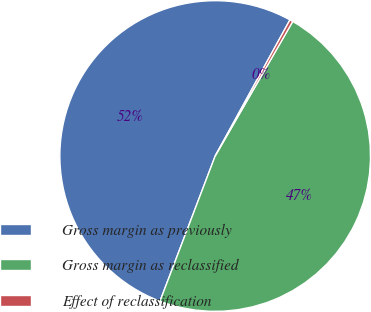Convert chart to OTSL. <chart><loc_0><loc_0><loc_500><loc_500><pie_chart><fcel>Gross margin as previously<fcel>Gross margin as reclassified<fcel>Effect of reclassification<nl><fcel>52.21%<fcel>47.46%<fcel>0.33%<nl></chart> 